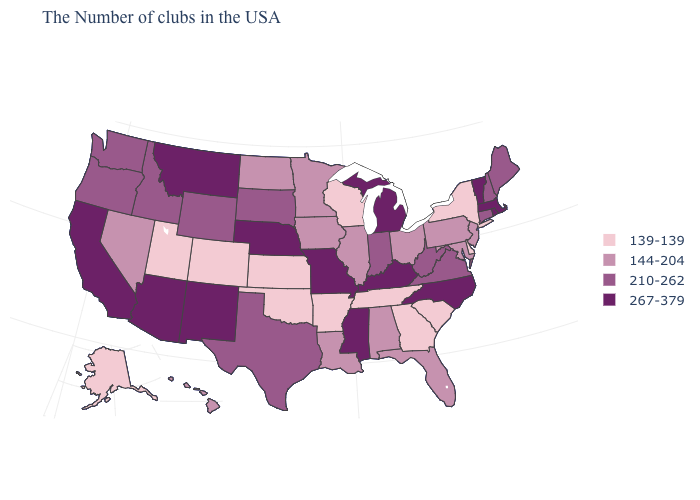What is the highest value in the MidWest ?
Quick response, please. 267-379. Does the first symbol in the legend represent the smallest category?
Give a very brief answer. Yes. Which states hav the highest value in the South?
Give a very brief answer. North Carolina, Kentucky, Mississippi. Which states have the lowest value in the Northeast?
Answer briefly. New York. Among the states that border New York , which have the highest value?
Keep it brief. Massachusetts, Vermont. Does New York have the lowest value in the USA?
Write a very short answer. Yes. Does the first symbol in the legend represent the smallest category?
Concise answer only. Yes. Is the legend a continuous bar?
Write a very short answer. No. What is the lowest value in the USA?
Be succinct. 139-139. What is the value of New York?
Keep it brief. 139-139. Which states hav the highest value in the Northeast?
Be succinct. Massachusetts, Rhode Island, Vermont. What is the lowest value in the South?
Be succinct. 139-139. Name the states that have a value in the range 139-139?
Concise answer only. New York, Delaware, South Carolina, Georgia, Tennessee, Wisconsin, Arkansas, Kansas, Oklahoma, Colorado, Utah, Alaska. Does Hawaii have the same value as Texas?
Keep it brief. No. Among the states that border Illinois , which have the lowest value?
Answer briefly. Wisconsin. 